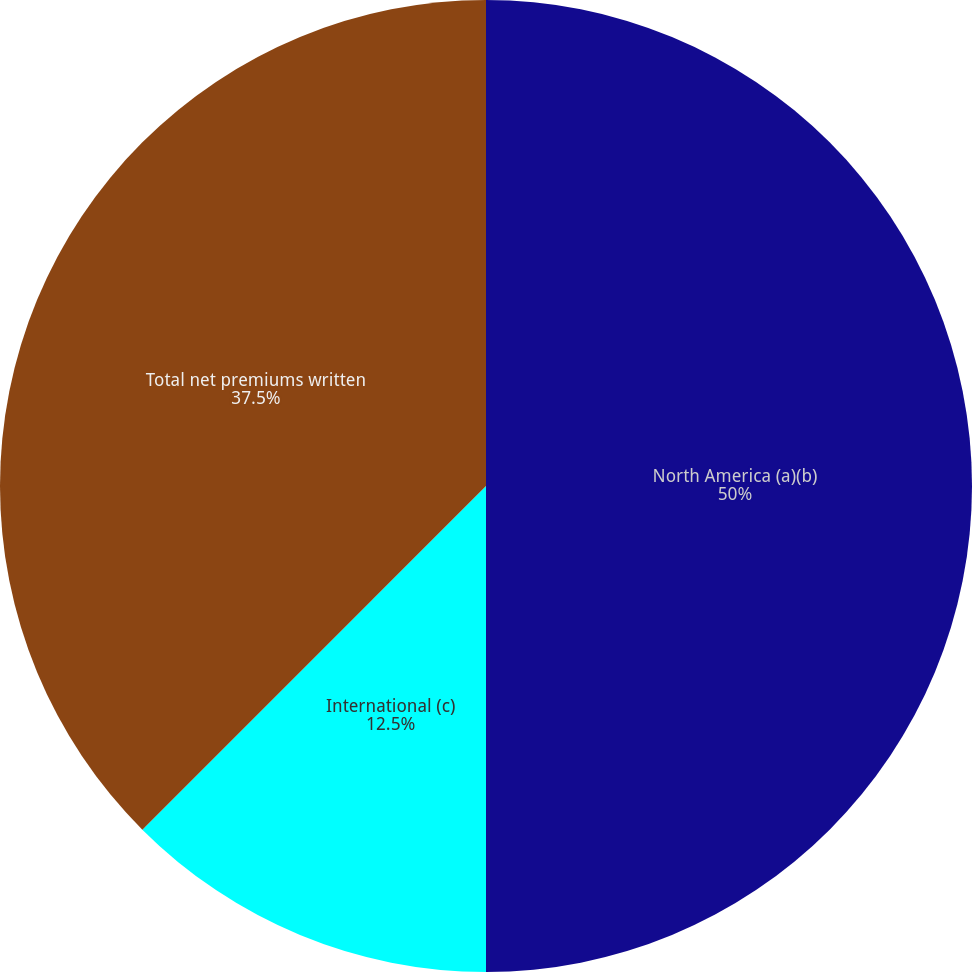Convert chart to OTSL. <chart><loc_0><loc_0><loc_500><loc_500><pie_chart><fcel>North America (a)(b)<fcel>International (c)<fcel>Total net premiums written<nl><fcel>50.0%<fcel>12.5%<fcel>37.5%<nl></chart> 